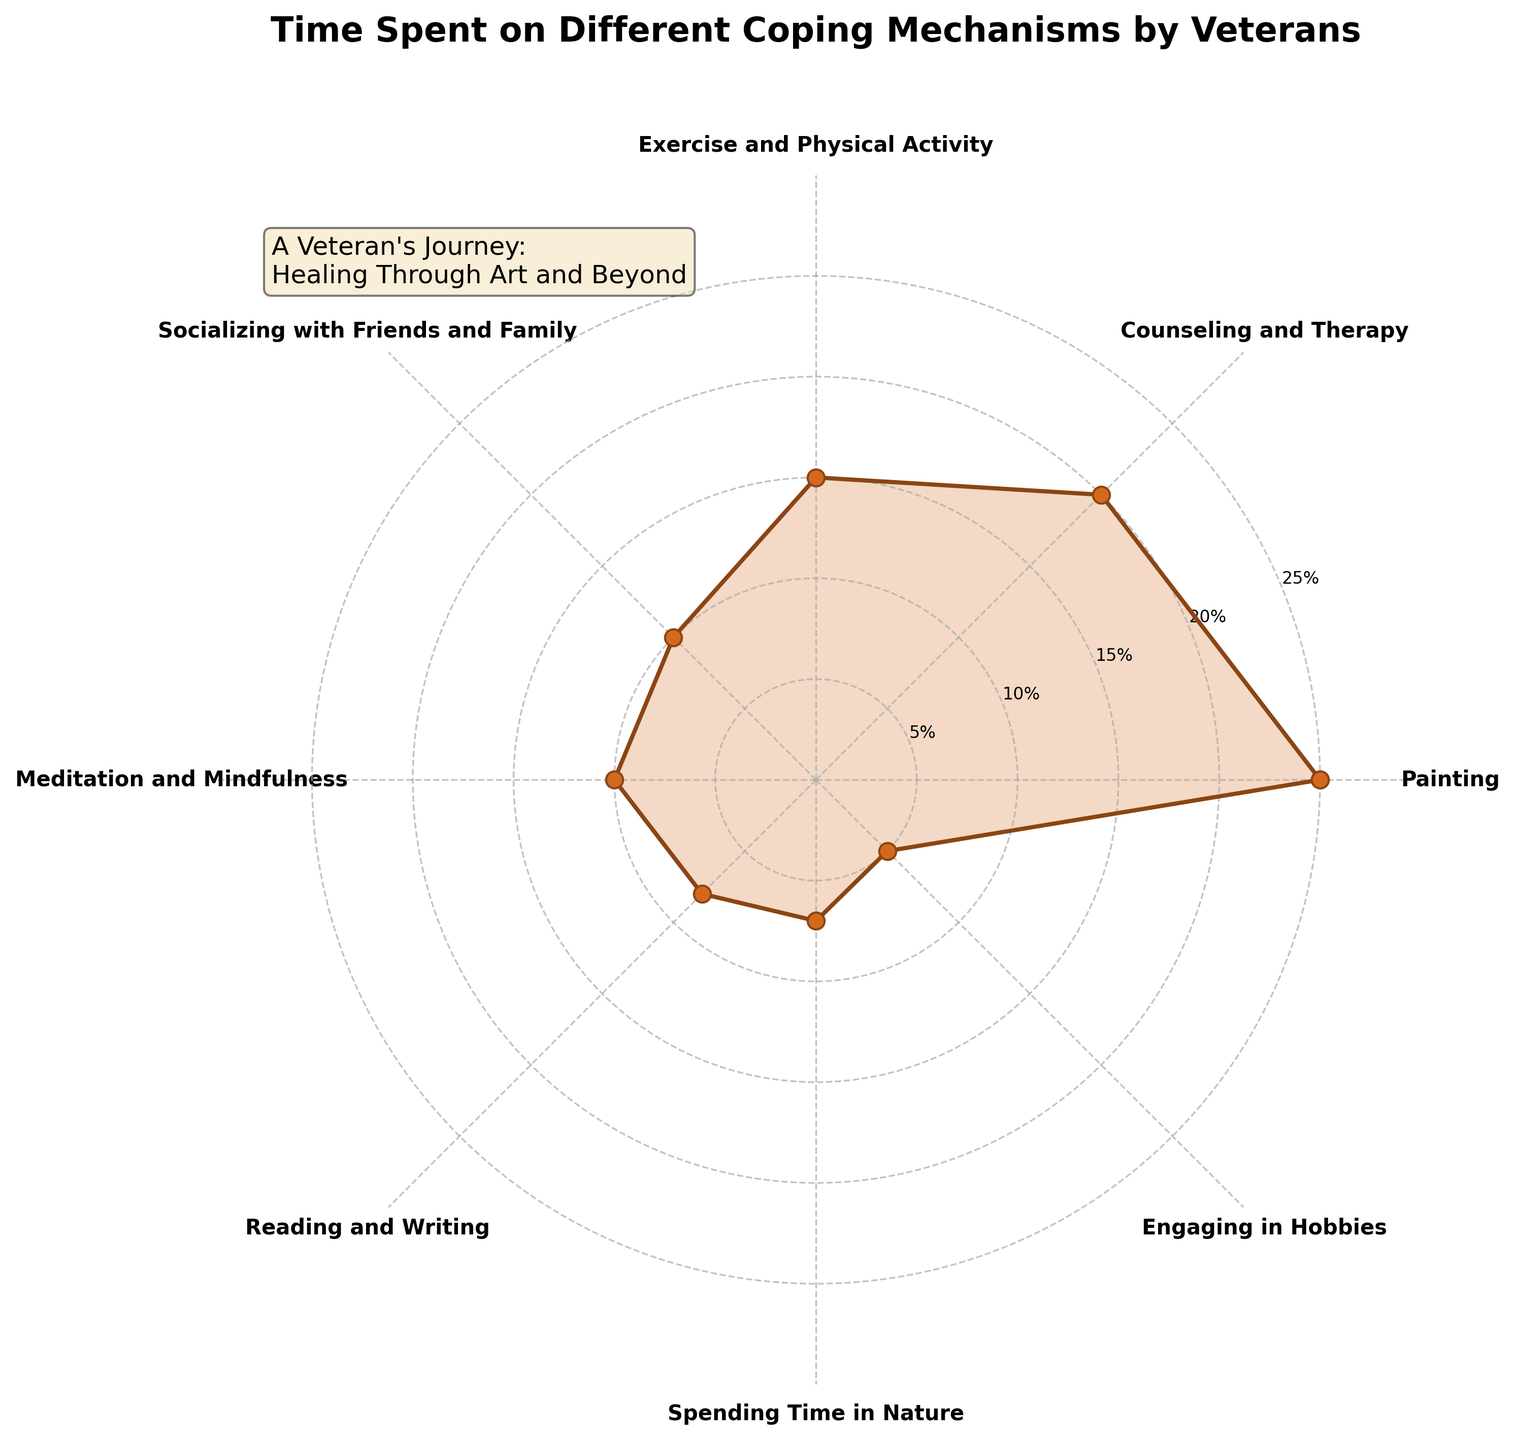What is the title of the polar chart? The title is usually found at the top of the chart and provides an idea of what the chart is about.
Answer: Time Spent on Different Coping Mechanisms by Veterans What coping mechanism do veterans spend the most time on? Look at the category with the highest value on the chart.
Answer: Painting Which coping mechanisms share the same percentage of time spent? Find the categories that have identical positions or percentages on the polar chart.
Answer: Socializing with Friends and Family and Meditation and Mindfulness How much more time do veterans spend on Painting compared to Reading and Writing? Subtract the time spent on Reading and Writing from the time spent on Painting. 25% - 8% = 17%
Answer: 17% Which coping mechanism do veterans spend the least time on? Find the category with the lowest value on the chart.
Answer: Engaging in Hobbies What is the combined percentage of time spent on Exercise and Physical Activity, and Engaging in Hobbies? Add the percentages for Exercise and Physical Activity, and Engaging in Hobbies. 15% + 5% = 20%
Answer: 20% What is the total percentage of time spent on Counseling and Therapy, and Spending Time in Nature? Add the percentages for Counseling and Therapy, and Spending Time in Nature. 20% + 7% = 27%
Answer: 27% What percentage of time is spent on all activities combined, except Painting? Subtract the percentage for Painting from the total percentage (which is 100%). 100% - 25% = 75%
Answer: 75% How does the time spent on Socializing with Friends and Family compare to the time spent on Meditation and Mindfulness? As they have the same value, the comparison will show they are equal.
Answer: They are equal What is the average time spent on all coping mechanisms? Sum all percentages and divide by the number of categories. (25% + 20% + 15% + 10% + 10% + 8% + 7% + 5%) / 8 = 100% / 8 = 12.5%
Answer: 12.5% 